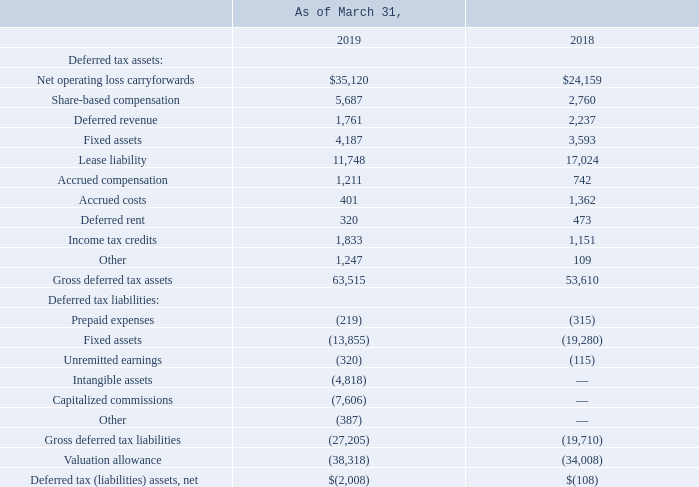Deferred tax assets and liabilities reflect the net tax effects of net operating loss carryovers and the temporary differences between the assets and liabilities carrying value for financial reporting and the amounts used for income tax purposes. The Company’s significant deferred tax assets (liabilities) components are as follows:
In assessing the ability to realize the Company’s net deferred tax assets, management considers various factors including taxable income in carryback years, future reversals of existing taxable temporary differences, tax planning strategies, and future taxable income projections to determine whether it is more likely than not that some portion or all of the net deferred tax assets will not be realized.
Based on the negative evidence, including the worldwide cumulative losses that the Company has incurred, the Company has determined that the uncertainty regarding realizing its deferred tax assets is sufficient to warrant the need for a full valuation allowance against its worldwide net deferred tax assets.
The $4.3 million net increase in the valuation allowance from 2018 to 2019 is primarily due to operating losses incurred and windfall tax benefits on equity awards in the current year, partially offset by the reduction in valuation allowance as a result of recording a net deferred tax liability associated with the adoption of ASC 606. In addition, the Company recognized a tax benefit of $1.0 million for the release of a portion of the Company’s pre-existing U.S. and U.K. valuation allowances as a result of the Ataata and Simply Migrate business combinations.
During the third quarter of fiscal 2018, the Tax Cuts and Jobs Act (the Act) was enacted in the United States. In addition, the Securities and Exchange Commission issued guidance under Staff Accounting Bulletin No. 118, Income Tax Accounting Implications of the Tax Cuts and Jobs Act (SAB 118) that directed taxpayers to consider the impact of the U.S. legislation as “provisional” when it did not have the necessary information available, prepared or analyzed (including computations) in reasonable detail to complete its accounting for the change in tax law.
During 2019, the Company has completed its accounting for the tax effects of the enactment of the Act. During the year ended March 31, 2019, the Company recognized an immaterial adjustment to the provisional estimate recorded related to the Act in the Company’s fiscal 2018 financial statements.
As of March 31, 2019, the Company had U.K. net operating loss carryforwards of approximately $57.4 million that do not expire. As of March 31, 2019, the Company had U.S. federal net operating loss carryforwards of approximately $78.6 million. U.S. federal net operating loss carryforwards generated through March 31, 2017 of approximately $32.5 million expire at various dates through 2037, and U.S. federal net operating loss carryforwards generated in the tax years beginning after March 31, 2017 of approximately $46.1 million do not expire.
As of March 31, 2019, the Company had U.S. state net operating loss carryforwards of approximately $54.6 million that expire at various dates through 2039. As of March 31, 2019, the Company had Australian net operating loss carryforwards of approximately $23.9 million that do not expire. As of March 31, 2019, the Company had German net operating loss carryforwards of approximately $9.9 million that do not expire.
As of March 31, 2019, the Company had Israeli net operating loss carryforwards of approximately $3.3 million that do not expire. As of March 31, 2019, the Company had a U.K. income tax credit carryforward of $1.1 million that does not expire. As of March 31, 2019, the Company had Israeli income tax credit carryforwards of $0.6 million that expires in 2023 and 2024.
Under Section 382 of the U.S. Internal Revenue Code, if a corporation undergoes an ownership change, the corporation’s ability to use its pre-change net operating loss carryforwards to offset its post-change income and taxes may be limited. In general, an ownership change occurs if there is a 50 percent cumulative change in ownership of the Company over a rolling three-year period. Similar rules may apply under U.S. state tax laws.
The Company believes that it has experienced an ownership change in the past and may experience ownership changes in the future resulting from future transactions in our share capital, some of which may be outside the Company’s control. The Company’s ability to utilize its net operating loss carryforwards or other tax attributes to offset U.S. federal and state taxable income in the future may be subject to future limitations.
As of March 31, 2019 and 2018, the Company had liabilities for uncertain tax positions of $6.0 million and $6.2 million, respectively, none of which, if recognized, would impact the Company’s effective tax rate.
What was the increase in the valuation allowance from 2018 to 2019? $4.3 million. What was the tax benefit recognized by the company? $1.0 million. What was the Net operating loss carryforwards in 2019 and 2018 respectively? $35,120, $24,159. What was the change in the Net operating loss carryforwards from 2018 to 2019? 35,120 - 24,159
Answer: 10961. What is the average Share-based compensation for 2018 and 2019? (5,687 + 2,760) / 2
Answer: 4223.5. In which year was Deferred revenue less than 2,000? Locate and analyze deferred revenue in row 6
answer: 2019. 